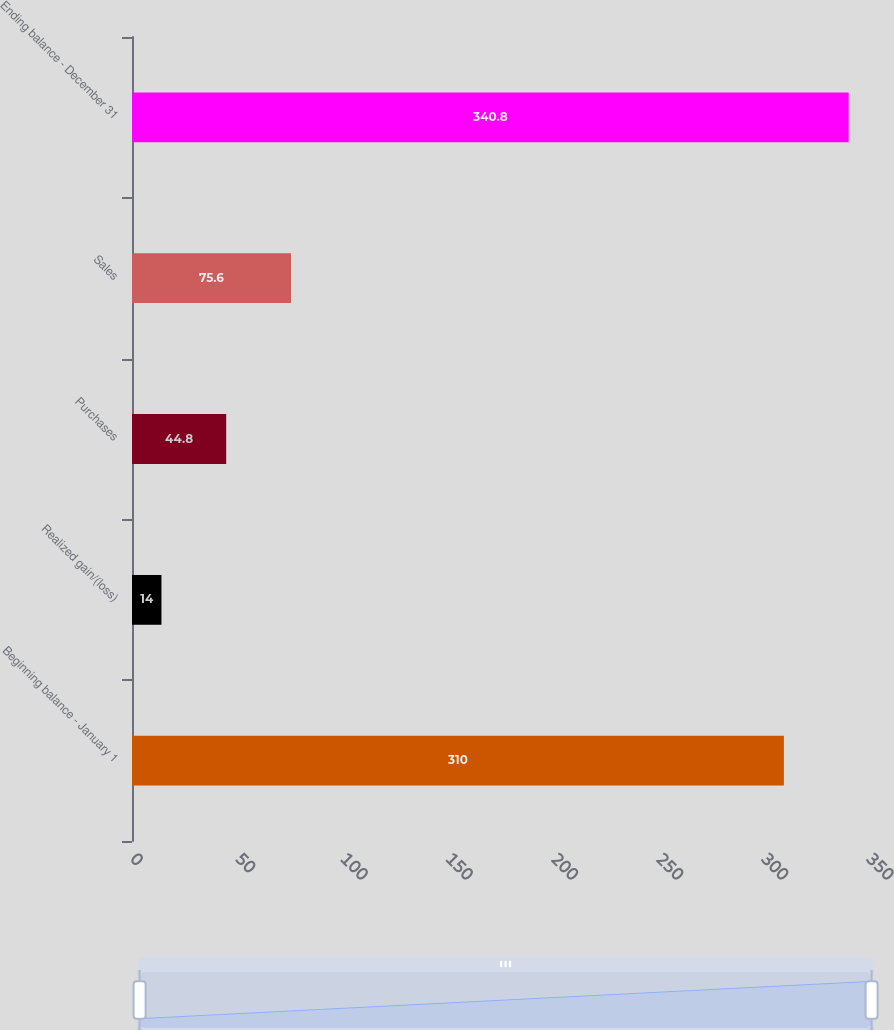<chart> <loc_0><loc_0><loc_500><loc_500><bar_chart><fcel>Beginning balance - January 1<fcel>Realized gain/(loss)<fcel>Purchases<fcel>Sales<fcel>Ending balance - December 31<nl><fcel>310<fcel>14<fcel>44.8<fcel>75.6<fcel>340.8<nl></chart> 